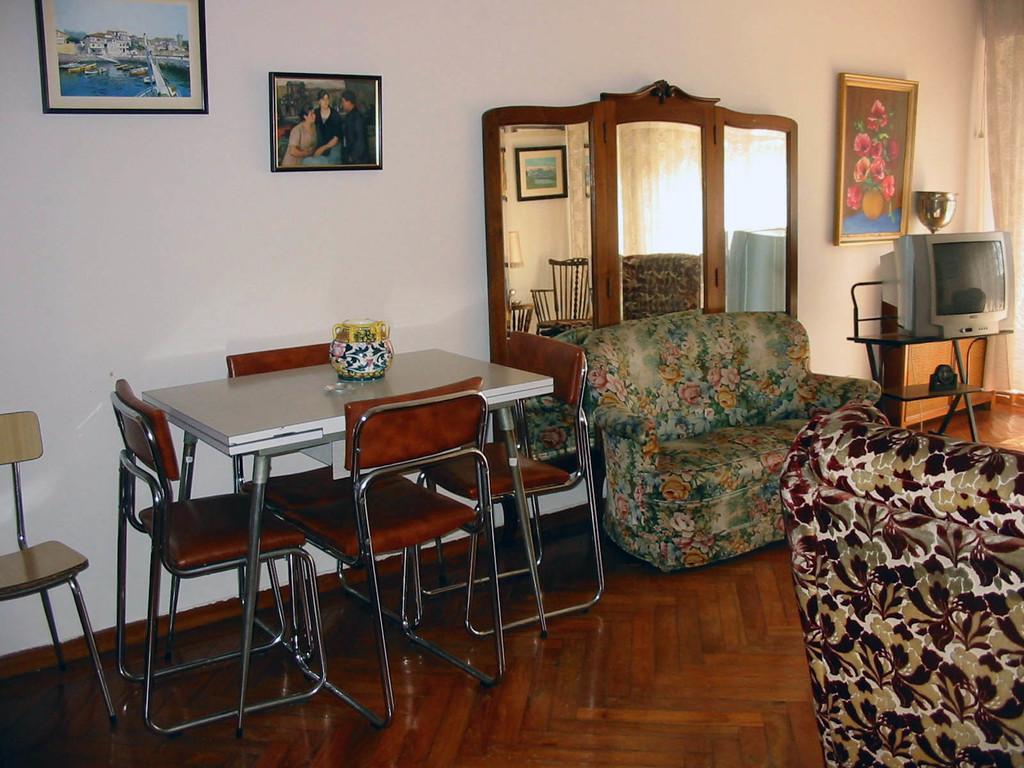Describe this image in one or two sentences. In this image i can see there is a table with few chairs on the other side. I can also see there is a TV and two couches on the floor. 